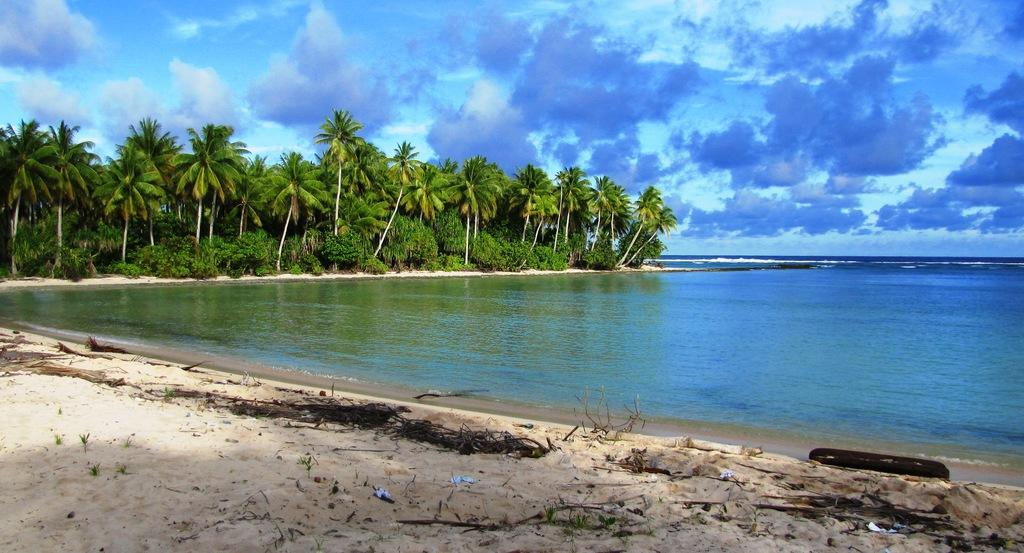What type of natural environment is depicted in the image? There is a beach in the image. What body of water is visible on the right side of the image? There is an ocean on the right side of the image. What type of terrain is present at the beach? There is sand in the image. What type of vegetation can be seen in the image? There are plants and trees in the image. What is the condition of the sky in the image? The sky is clear in the image. What is the queen's tendency when it comes to playing with toys in the image? There is no queen or toys present in the image; it depicts a beach setting with an ocean, sand, plants, trees, and a clear sky. 